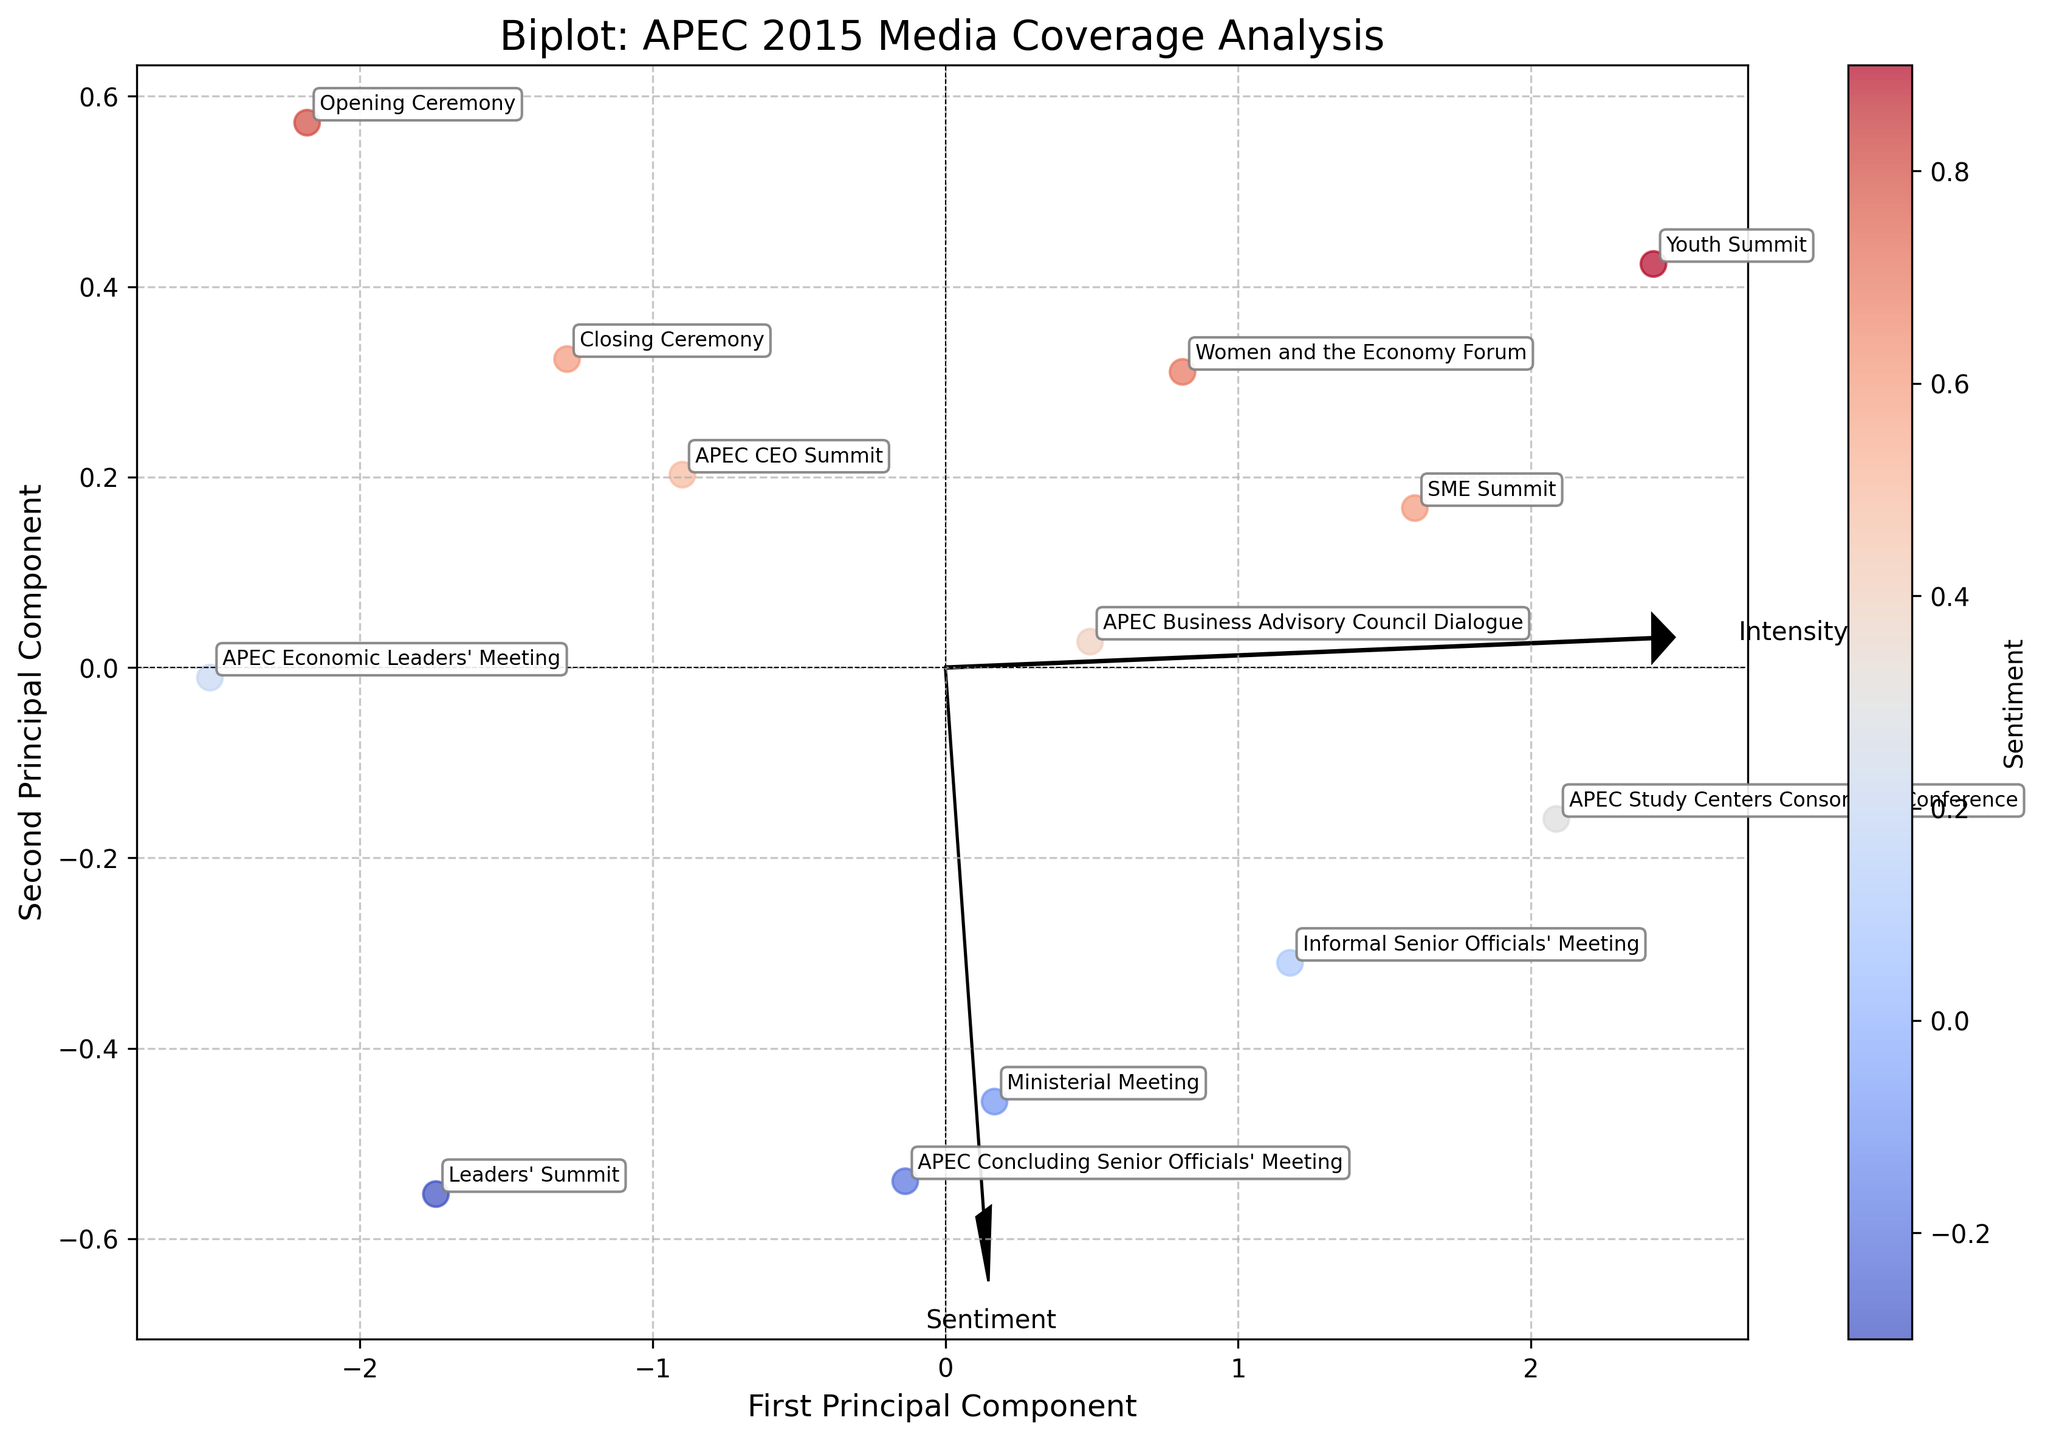What is the title of the figure? The title is usually at the top of the plot and provides a brief overview of what the figure represents. Here, it states "Biplot: APEC 2015 Media Coverage Analysis".
Answer: Biplot: APEC 2015 Media Coverage Analysis How many data points are plotted in the figure? Each data point corresponds to an event, and from the data, there are distinct events listed. There are 13 events making up 13 data points.
Answer: 13 Which event has the highest media coverage sentiment? Look for the data point with the highest value on the plot's sentiment axis. The Youth Summit has the highest positive sentiment (0.9).
Answer: Youth Summit Which event has the highest intensity of media coverage? Intensity is represented on the plot, and the APEC Economic Leaders' Meeting has the highest intensity (9.5).
Answer: APEC Economic Leaders' Meeting Which event shows the most negative sentiment? The event that appears lowest on the sentiment scale in the plot is the Leaders' Summit (-0.3).
Answer: Leaders' Summit How do the Sentiment and Intensity vectors relate to the overall distribution of events? The vectors emanate from the origin and typically point towards higher values in their respective directions. Sentiment and Intensity vectors can be used to interpret the direction and magnitude of changes. In this plot, most of the events have a positive sentiment, with varying intensities.
Answer: Most events have positive sentiment and varying intensities Which two events have similar Principal Component 1 (PC1) values? Look for data points that align closely on the PC1 axis. The Opening Ceremony and APEC CEO Summit appear to share similar values on the PC1 axis.
Answer: Opening Ceremony and APEC CEO Summit Which event is represented by the point furthest to the right on the plot's x-axis? Identify the point on the far right side of the x-axis (PC1). The Opening Ceremony is the event furthest to the right.
Answer: Opening Ceremony What can be said about the media coverage sentiment for the "Ministerial Meeting" compared to the "APEC Concluding Senior Officials' Meeting"? Comparing the sentiment values directly on the plot, the Ministerial Meeting has a slightly less negative sentiment (-0.1) than the APEC Concluding Senior Officials' Meeting (-0.2).
Answer: Ministerial Meeting has a slightly less negative sentiment 